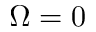Convert formula to latex. <formula><loc_0><loc_0><loc_500><loc_500>\Omega = 0</formula> 